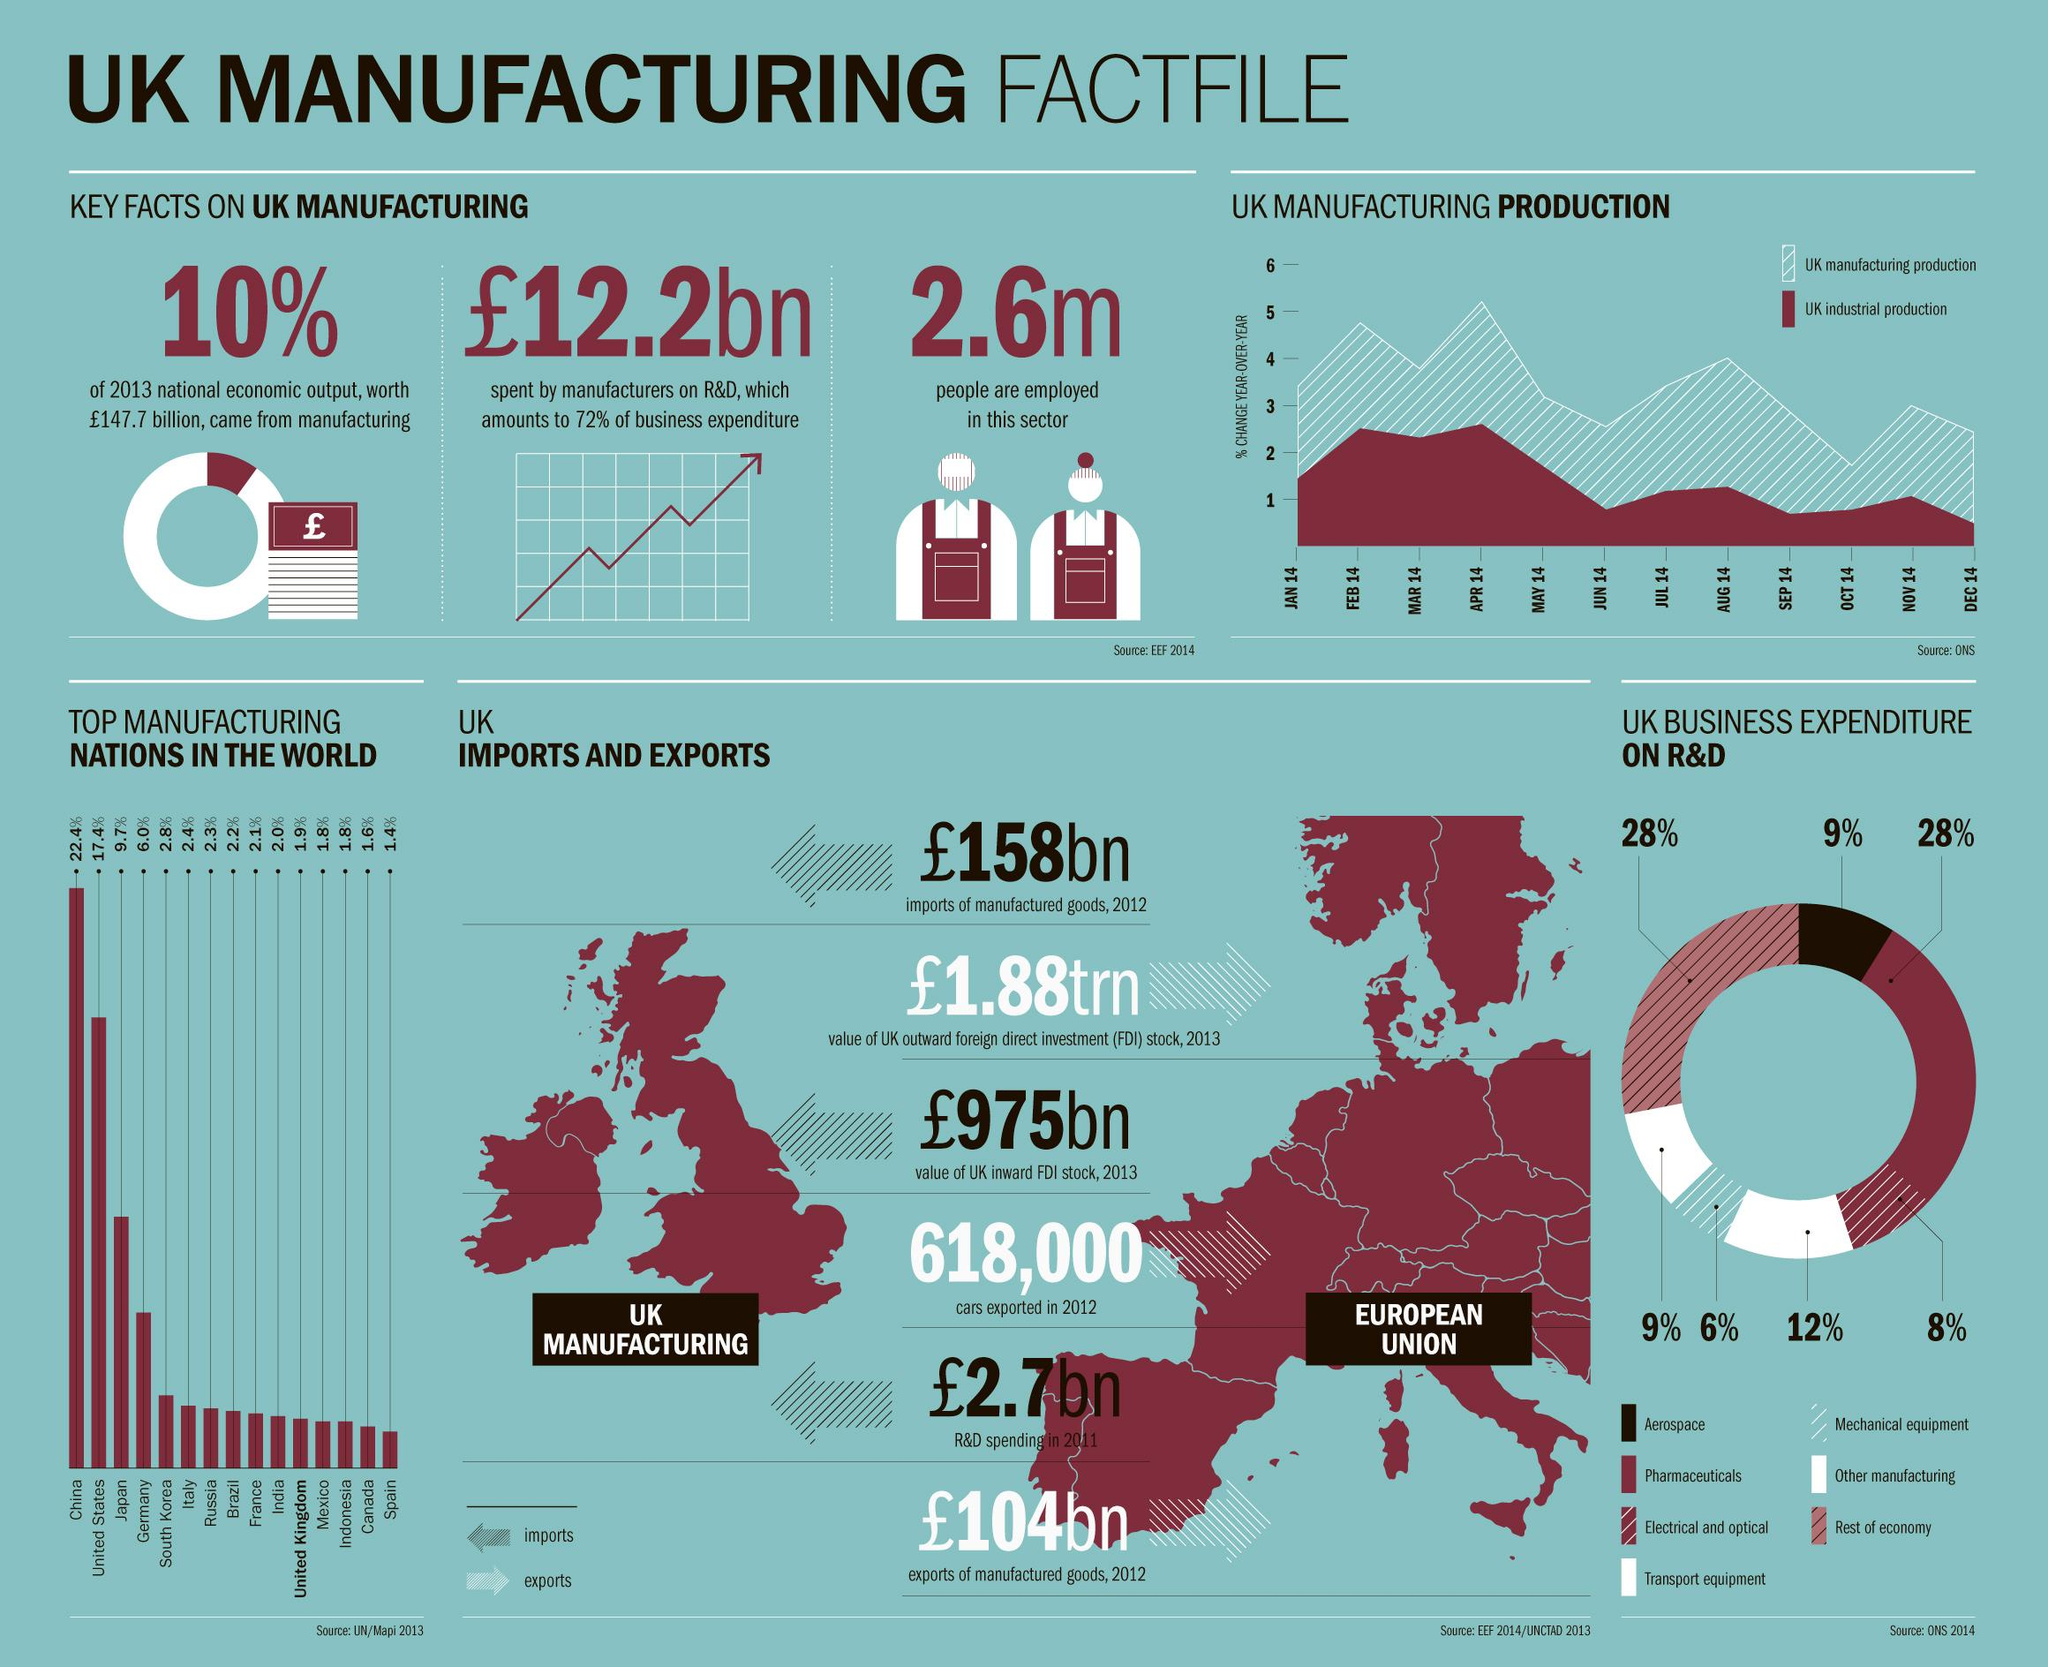Specify some key components in this picture. In 2014, the percentage of UK business expenditure on mechanical equipment R&D was 6%. In 2013, China was the top manufacturing nation in the world. In 2013, manufacturing contributed approximately 10% of the national economic output in the United Kingdom. In 2013, the population of employees in the UK manufacturing sector was approximately 2.6 million. The export value of manufactured goods in the UK in 2012 was £104 billion. 